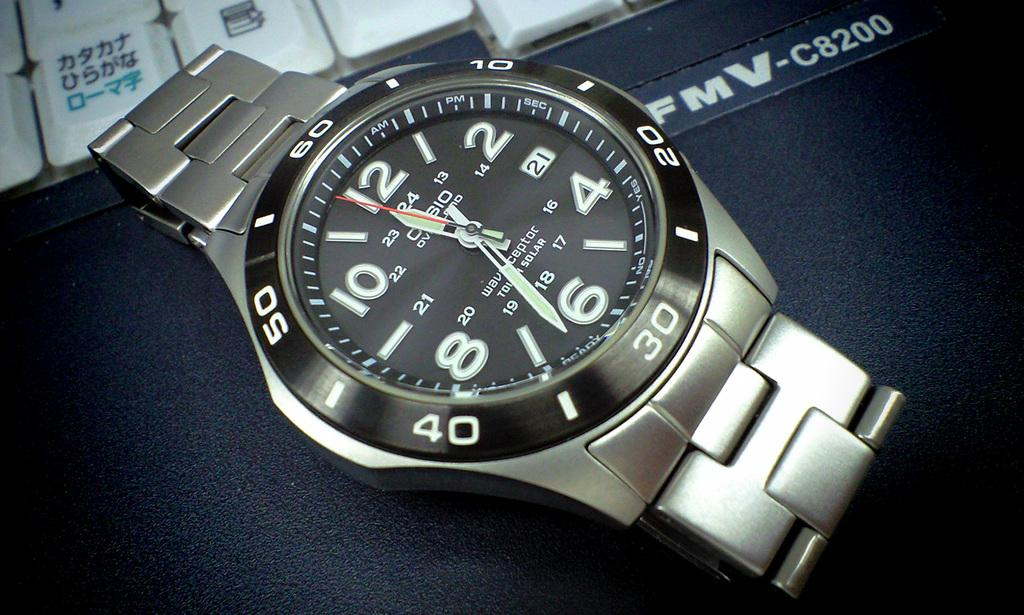<image>
Present a compact description of the photo's key features. Silver stopwatch with the word CASIO on the black face. 